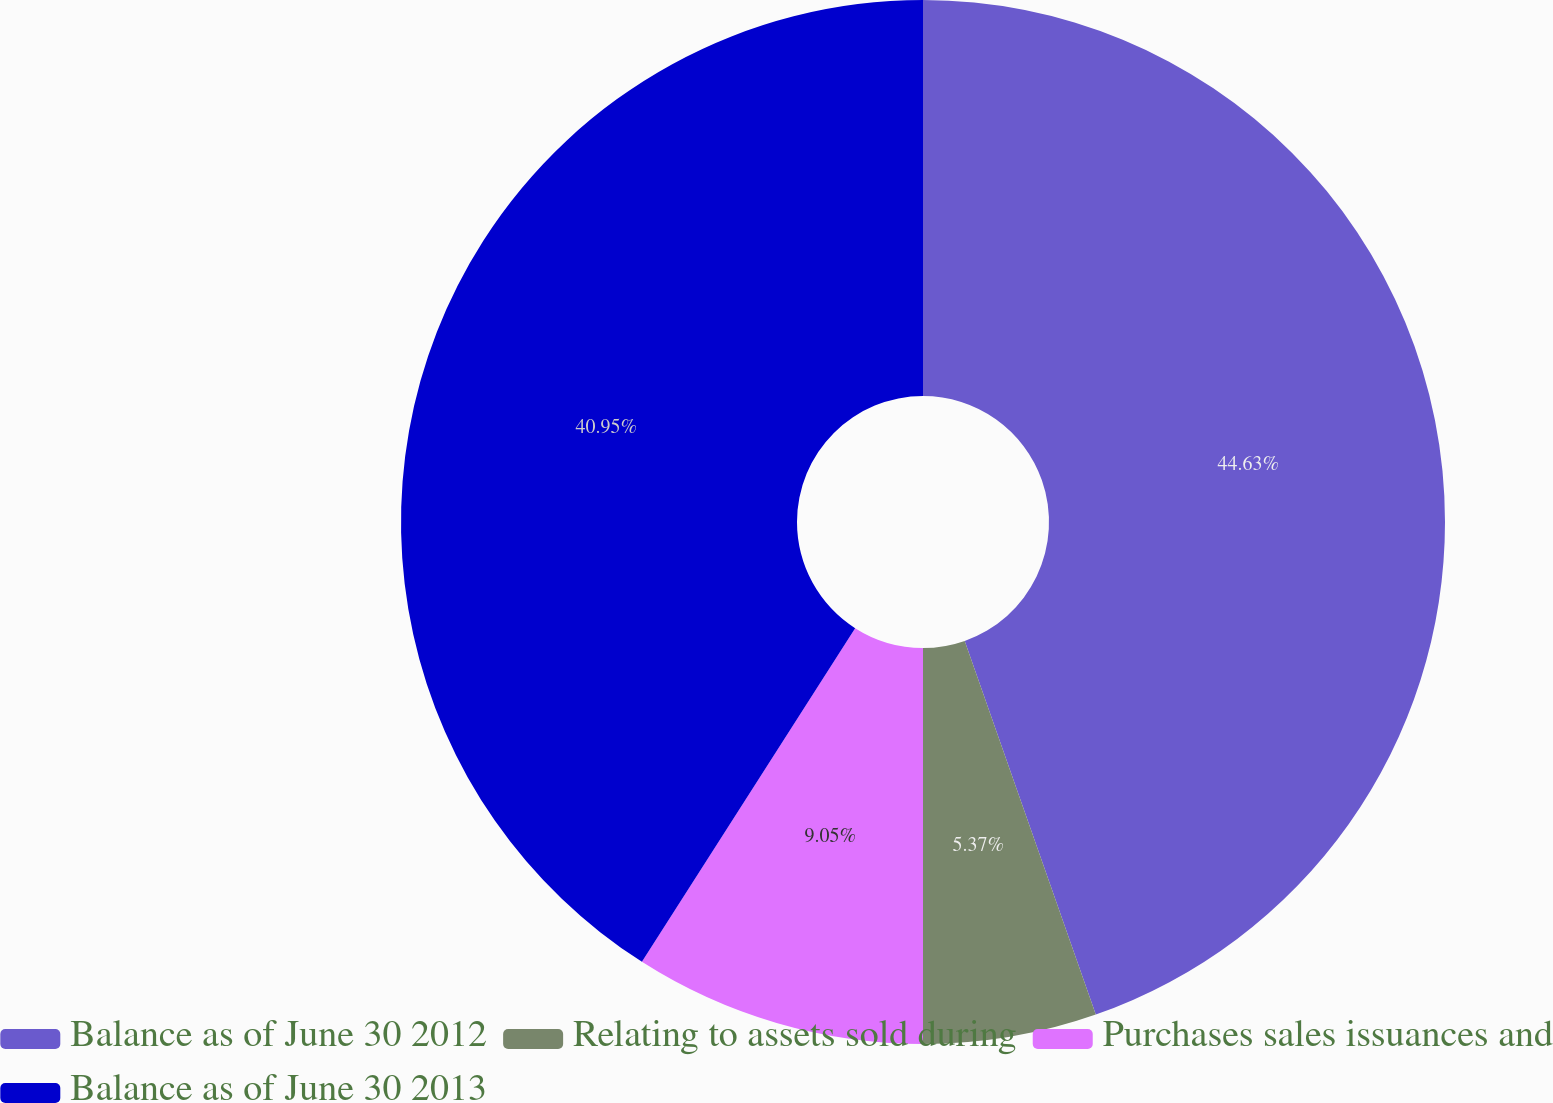<chart> <loc_0><loc_0><loc_500><loc_500><pie_chart><fcel>Balance as of June 30 2012<fcel>Relating to assets sold during<fcel>Purchases sales issuances and<fcel>Balance as of June 30 2013<nl><fcel>44.63%<fcel>5.37%<fcel>9.05%<fcel>40.95%<nl></chart> 